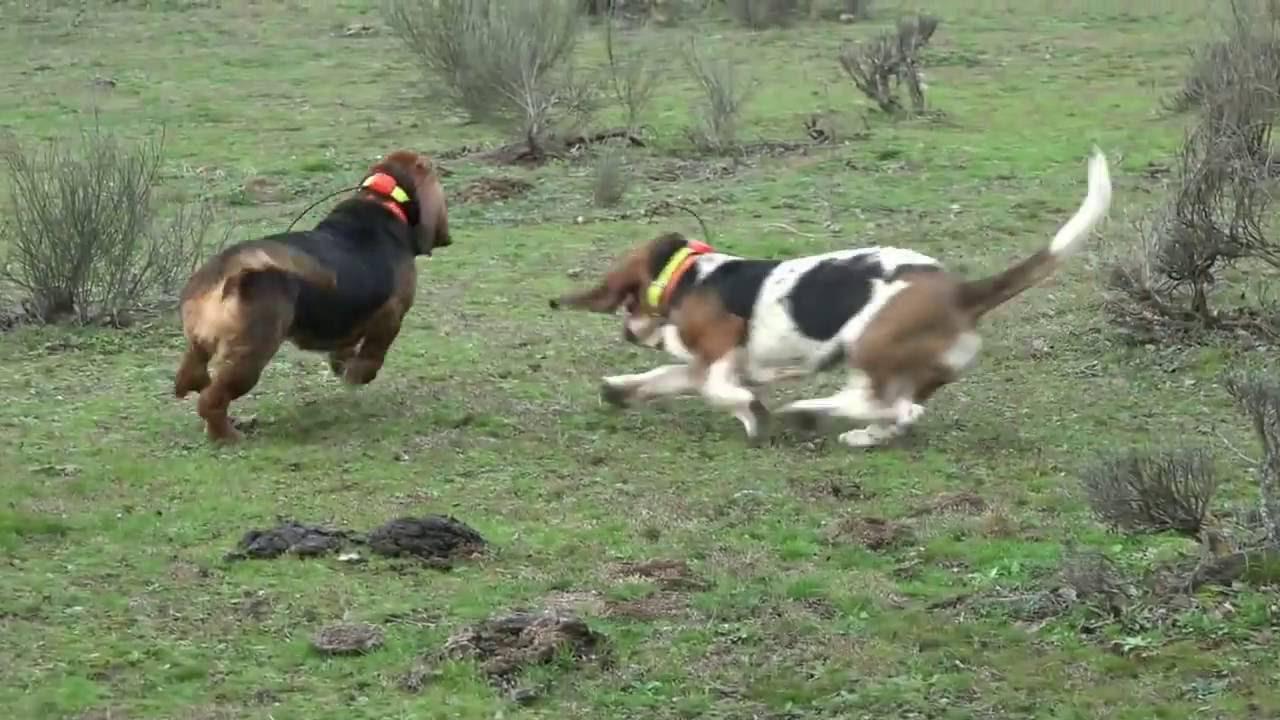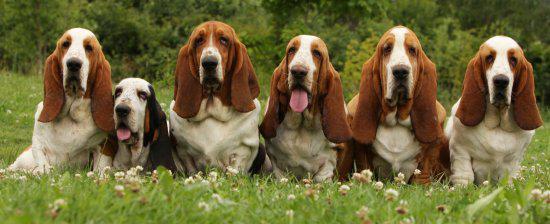The first image is the image on the left, the second image is the image on the right. Analyze the images presented: Is the assertion "There are four dogs outside in the image on the left." valid? Answer yes or no. No. 